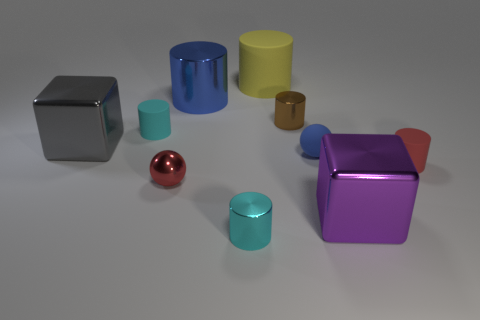What material is the thing that is the same color as the rubber sphere?
Make the answer very short. Metal. What color is the other object that is the same shape as the purple object?
Ensure brevity in your answer.  Gray. There is a cyan cylinder in front of the gray metal cube; does it have the same size as the small red rubber thing?
Make the answer very short. Yes. What is the big gray object made of?
Provide a short and direct response. Metal. The tiny thing on the right side of the purple metal object is what color?
Provide a short and direct response. Red. How many tiny objects are either green cubes or purple objects?
Your response must be concise. 0. There is a shiny block right of the big blue metallic cylinder; is its color the same as the small matte object to the right of the large purple metallic block?
Provide a short and direct response. No. What number of other things are there of the same color as the metal sphere?
Make the answer very short. 1. What number of gray things are either large things or small things?
Provide a short and direct response. 1. There is a tiny red metal thing; is its shape the same as the matte object right of the matte sphere?
Your answer should be very brief. No. 